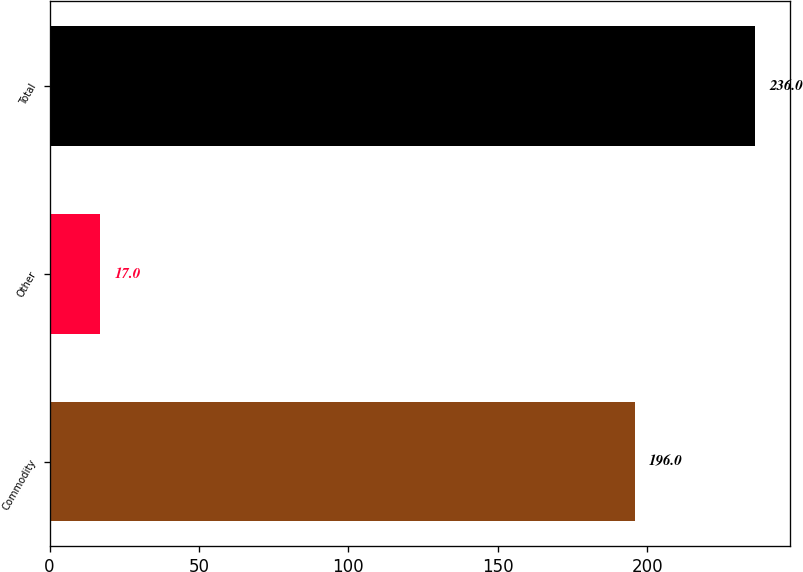Convert chart. <chart><loc_0><loc_0><loc_500><loc_500><bar_chart><fcel>Commodity<fcel>Other<fcel>Total<nl><fcel>196<fcel>17<fcel>236<nl></chart> 